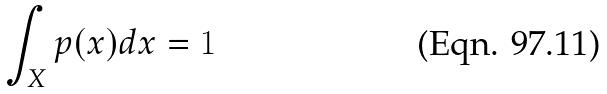<formula> <loc_0><loc_0><loc_500><loc_500>\int _ { X } p ( x ) d x = 1</formula> 